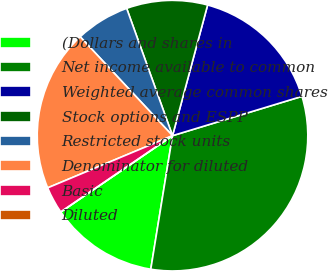<chart> <loc_0><loc_0><loc_500><loc_500><pie_chart><fcel>(Dollars and shares in<fcel>Net income available to common<fcel>Weighted average common shares<fcel>Stock options and ESPP<fcel>Restricted stock units<fcel>Denominator for diluted<fcel>Basic<fcel>Diluted<nl><fcel>12.9%<fcel>32.26%<fcel>16.13%<fcel>9.68%<fcel>6.45%<fcel>19.35%<fcel>3.23%<fcel>0.0%<nl></chart> 